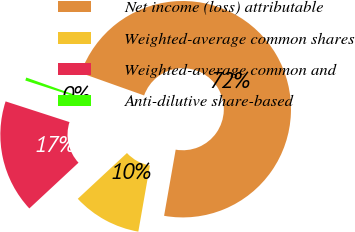<chart> <loc_0><loc_0><loc_500><loc_500><pie_chart><fcel>Net income (loss) attributable<fcel>Weighted-average common shares<fcel>Weighted-average common and<fcel>Anti-dilutive share-based<nl><fcel>72.31%<fcel>10.31%<fcel>16.91%<fcel>0.46%<nl></chart> 